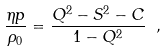<formula> <loc_0><loc_0><loc_500><loc_500>\frac { \eta p } { \rho _ { 0 } } = \frac { Q ^ { 2 } - S ^ { 2 } - C } { 1 - Q ^ { 2 } } \ ,</formula> 